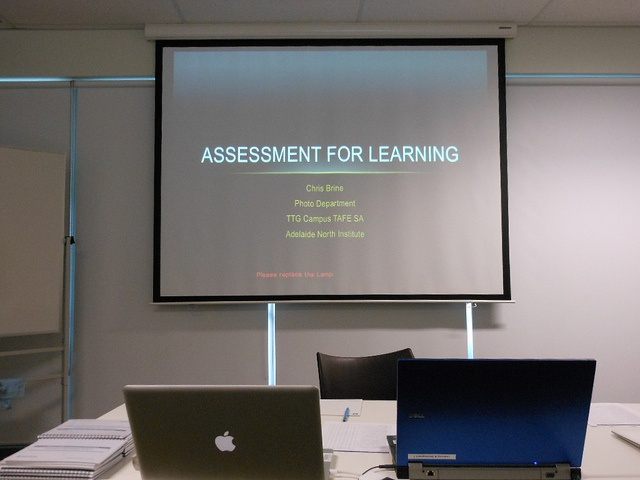Describe the objects in this image and their specific colors. I can see tv in black, gray, and darkgray tones, laptop in black, navy, and gray tones, laptop in black, darkgray, and gray tones, book in black, darkgray, and gray tones, and chair in black and gray tones in this image. 